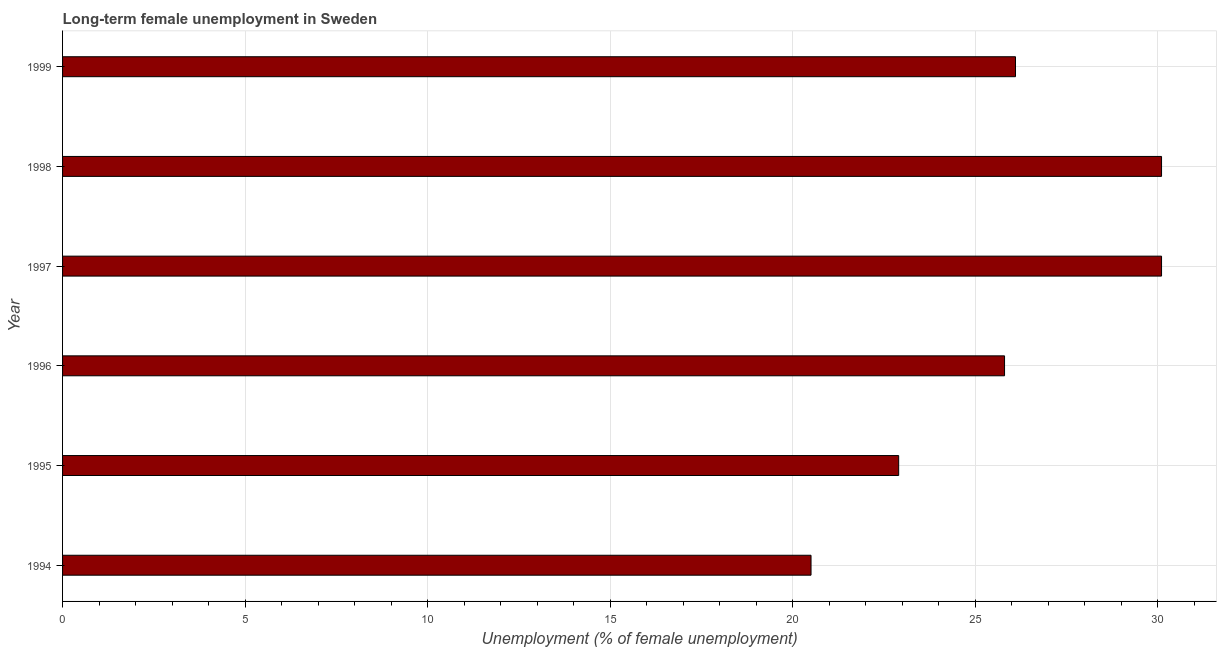Does the graph contain grids?
Provide a short and direct response. Yes. What is the title of the graph?
Provide a succinct answer. Long-term female unemployment in Sweden. What is the label or title of the X-axis?
Your response must be concise. Unemployment (% of female unemployment). What is the label or title of the Y-axis?
Make the answer very short. Year. What is the long-term female unemployment in 1997?
Give a very brief answer. 30.1. Across all years, what is the maximum long-term female unemployment?
Your answer should be very brief. 30.1. In which year was the long-term female unemployment minimum?
Offer a very short reply. 1994. What is the sum of the long-term female unemployment?
Make the answer very short. 155.5. What is the difference between the long-term female unemployment in 1994 and 1995?
Keep it short and to the point. -2.4. What is the average long-term female unemployment per year?
Ensure brevity in your answer.  25.92. What is the median long-term female unemployment?
Ensure brevity in your answer.  25.95. Do a majority of the years between 1998 and 1997 (inclusive) have long-term female unemployment greater than 7 %?
Your response must be concise. No. What is the ratio of the long-term female unemployment in 1996 to that in 1998?
Provide a short and direct response. 0.86. Is the sum of the long-term female unemployment in 1995 and 1999 greater than the maximum long-term female unemployment across all years?
Your answer should be very brief. Yes. What is the difference between the highest and the lowest long-term female unemployment?
Provide a succinct answer. 9.6. In how many years, is the long-term female unemployment greater than the average long-term female unemployment taken over all years?
Offer a very short reply. 3. How many bars are there?
Offer a very short reply. 6. Are the values on the major ticks of X-axis written in scientific E-notation?
Your answer should be very brief. No. What is the Unemployment (% of female unemployment) of 1994?
Your answer should be very brief. 20.5. What is the Unemployment (% of female unemployment) in 1995?
Ensure brevity in your answer.  22.9. What is the Unemployment (% of female unemployment) of 1996?
Your answer should be compact. 25.8. What is the Unemployment (% of female unemployment) of 1997?
Make the answer very short. 30.1. What is the Unemployment (% of female unemployment) of 1998?
Your response must be concise. 30.1. What is the Unemployment (% of female unemployment) in 1999?
Provide a short and direct response. 26.1. What is the difference between the Unemployment (% of female unemployment) in 1994 and 1997?
Offer a terse response. -9.6. What is the difference between the Unemployment (% of female unemployment) in 1994 and 1999?
Keep it short and to the point. -5.6. What is the difference between the Unemployment (% of female unemployment) in 1995 and 1996?
Make the answer very short. -2.9. What is the difference between the Unemployment (% of female unemployment) in 1995 and 1997?
Provide a short and direct response. -7.2. What is the difference between the Unemployment (% of female unemployment) in 1995 and 1998?
Give a very brief answer. -7.2. What is the difference between the Unemployment (% of female unemployment) in 1995 and 1999?
Your answer should be very brief. -3.2. What is the difference between the Unemployment (% of female unemployment) in 1996 and 1998?
Keep it short and to the point. -4.3. What is the difference between the Unemployment (% of female unemployment) in 1998 and 1999?
Make the answer very short. 4. What is the ratio of the Unemployment (% of female unemployment) in 1994 to that in 1995?
Your answer should be compact. 0.9. What is the ratio of the Unemployment (% of female unemployment) in 1994 to that in 1996?
Offer a terse response. 0.8. What is the ratio of the Unemployment (% of female unemployment) in 1994 to that in 1997?
Offer a very short reply. 0.68. What is the ratio of the Unemployment (% of female unemployment) in 1994 to that in 1998?
Provide a succinct answer. 0.68. What is the ratio of the Unemployment (% of female unemployment) in 1994 to that in 1999?
Keep it short and to the point. 0.79. What is the ratio of the Unemployment (% of female unemployment) in 1995 to that in 1996?
Provide a short and direct response. 0.89. What is the ratio of the Unemployment (% of female unemployment) in 1995 to that in 1997?
Your answer should be compact. 0.76. What is the ratio of the Unemployment (% of female unemployment) in 1995 to that in 1998?
Offer a terse response. 0.76. What is the ratio of the Unemployment (% of female unemployment) in 1995 to that in 1999?
Ensure brevity in your answer.  0.88. What is the ratio of the Unemployment (% of female unemployment) in 1996 to that in 1997?
Provide a short and direct response. 0.86. What is the ratio of the Unemployment (% of female unemployment) in 1996 to that in 1998?
Your answer should be compact. 0.86. What is the ratio of the Unemployment (% of female unemployment) in 1996 to that in 1999?
Provide a short and direct response. 0.99. What is the ratio of the Unemployment (% of female unemployment) in 1997 to that in 1999?
Provide a succinct answer. 1.15. What is the ratio of the Unemployment (% of female unemployment) in 1998 to that in 1999?
Make the answer very short. 1.15. 